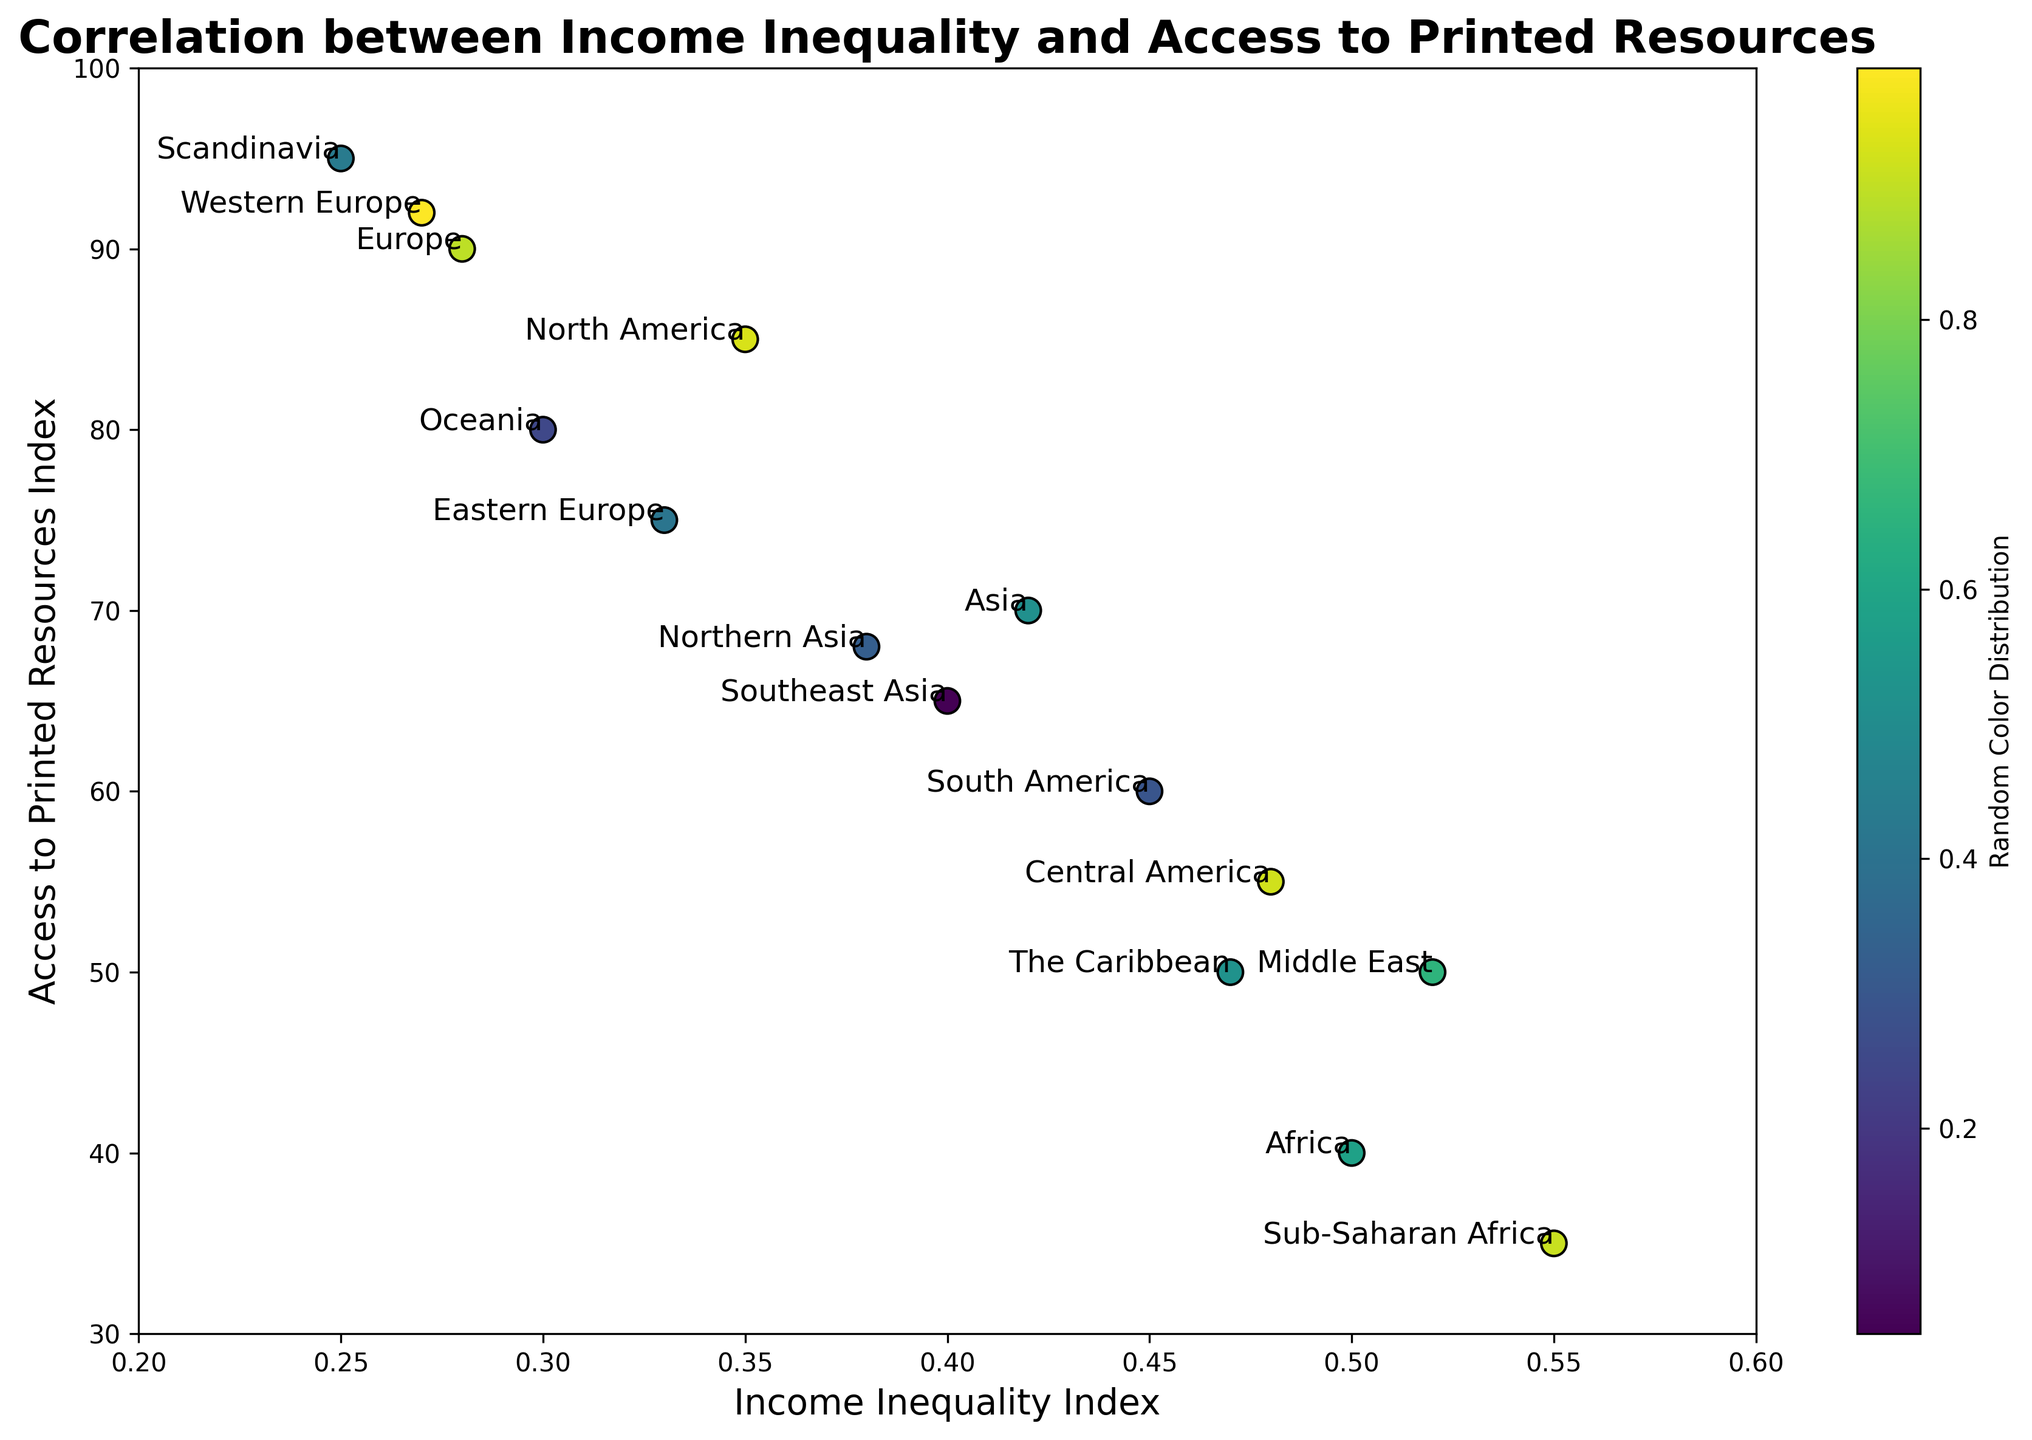Which region has the highest access to printed resources? The region with the highest access to printed resources has the highest 'Access to Printed Resources Index'. From the scatter plot, Scandinavia has the highest value of 95.
Answer: Scandinavia Which regions have an Income Inequality Index greater than 0.45? Look for data points scattered beyond the 0.45 mark on the horizontal axis for 'Income Inequality Index'. The regions meeting this criterion are Africa, South America, Central America, Middle East, Sub-Saharan Africa, and The Caribbean.
Answer: Africa, South America, Central America, Middle East, Sub-Saharan Africa, The Caribbean What is the general trend between Income Inequality Index and Access to Printed Resources Index? Observe the overall arrangement of the data points. As the Income Inequality Index increases (move to the right on the x-axis), the Access to Printed Resources Index generally decreases (points go lower on the y-axis), indicating a negative correlation.
Answer: Negative correlation Which regions have both an Income Inequality Index less than 0.35 and an Access to Printed Resources Index greater than 85? Identify regions where the data points are both to the left of 0.35 on the x-axis and above 85 on the y-axis. The suitable regions are Western Europe and Scandinavia.
Answer: Western Europe, Scandinavia Is there any region with an Income Inequality Index around 0.30 and Access to Printed Resources Index around 80? Check data points near 0.30 on the x-axis and about 80 on the y-axis. Oceania fits this description.
Answer: Oceania Which two regions have the closest Access to Printed Resources Index but vastly different Income Inequality Index? Identify regions with similar y-axis values but differing x-axis values. Europe (90) and Western Europe (92) have a close 'Access to Printed Resources Index', but Europe (0.28) has a lower 'Income Inequality Index' than Western Europe (0.27).
Answer: Europe, Western Europe What is the average Access to Printed Resources Index of regions with an Income Inequality Index below 0.30? Average the 'Access to Printed Resources Index' of regions with 'Income Inequality Index' values below 0.30 (Europe, Oceania, Scandinavia, Western Europe). The indices are 90, 80, 95, and 92, respectively. The average is (90 + 80 + 95 + 92)/4 = 89.25.
Answer: 89.25 Does any region have the same 'Income Inequality Index' as Asia? If yes, which one? Look for a data point on the x-axis that aligns with Asia’s 'Income Inequality Index' of 0.42. No other region shares this exact value.
Answer: No Which region with an Income Inequality Index of at least 0.50 has the highest 'Access to Printed Resources Index'? Focus on regions with an x-axis value of 0.50 or more and compare their y-axis values. The Middle East (50) is higher than Sub-Saharan Africa (35).
Answer: The Middle East 